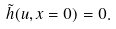Convert formula to latex. <formula><loc_0><loc_0><loc_500><loc_500>\tilde { h } ( u , x = 0 ) = 0 .</formula> 